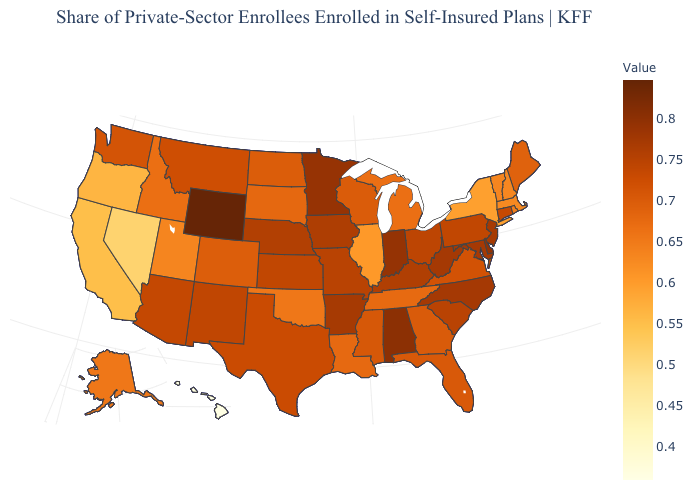Among the states that border New Hampshire , does Maine have the highest value?
Answer briefly. Yes. Which states have the lowest value in the USA?
Answer briefly. Hawaii. Among the states that border Kansas , does Nebraska have the highest value?
Answer briefly. Yes. Does the map have missing data?
Concise answer only. No. Among the states that border Virginia , which have the highest value?
Short answer required. Maryland, North Carolina, West Virginia. Among the states that border Arizona , which have the highest value?
Short answer required. New Mexico. Which states have the highest value in the USA?
Short answer required. Wyoming. 